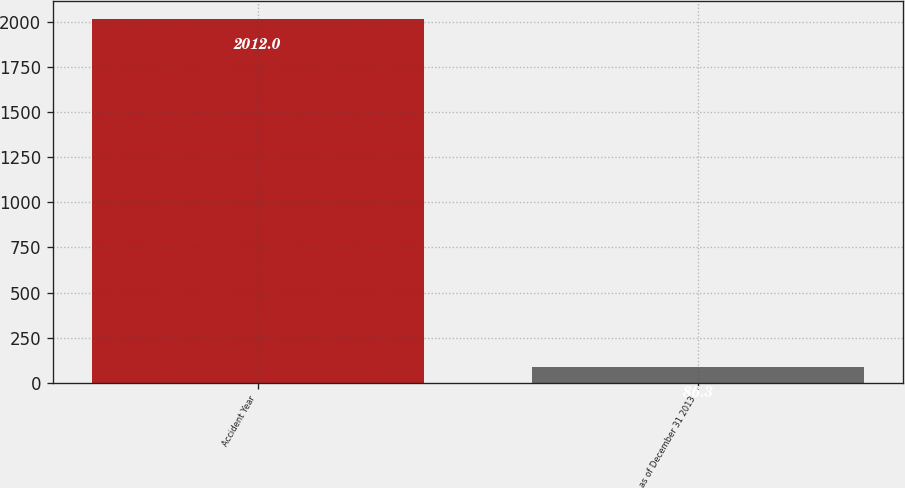Convert chart to OTSL. <chart><loc_0><loc_0><loc_500><loc_500><bar_chart><fcel>Accident Year<fcel>as of December 31 2013<nl><fcel>2012<fcel>86.3<nl></chart> 